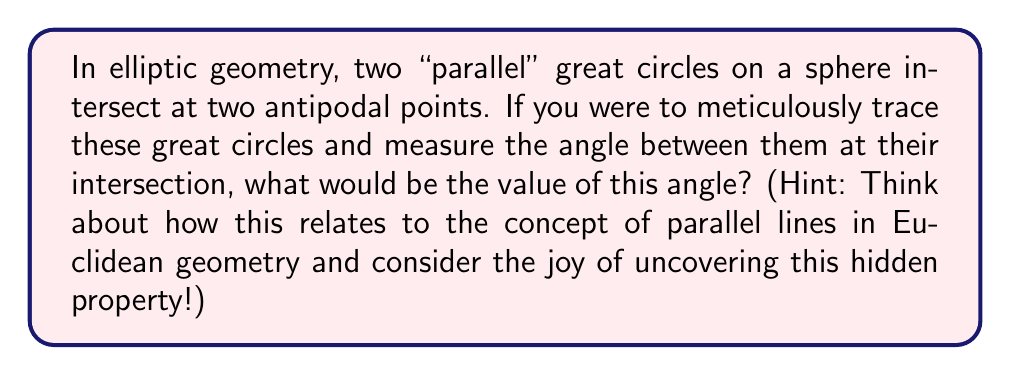Show me your answer to this math problem. Let's approach this step-by-step:

1) First, recall that in elliptic geometry, we work on the surface of a sphere. Great circles on a sphere are the equivalent of straight lines in Euclidean geometry.

2) In Euclidean geometry, parallel lines never intersect and the angle between them is always 0°.

3) However, in elliptic geometry, all great circles intersect at two antipodal points. This is a fundamental difference from Euclidean geometry.

4) To determine the angle of intersection, let's consider the properties of great circles:

   a) Any two great circles divide the sphere into four equal parts.
   b) These four parts are congruent spherical lunes.

5) Given that the great circles divide the sphere into four equal parts, each part must represent 1/4 of the full rotation around the sphere.

6) A full rotation is 360°. Therefore, each of the four parts represents:

   $$\frac{360°}{4} = 90°$$

7) The angle between the great circles at their intersection points is the same as the angle of these spherical lunes.

8) Therefore, the angle between any two great circles at their intersection is always 90°.

This result is a fascinating "easter egg" of elliptic geometry, showing how dramatically different it is from Euclidean geometry despite some superficial similarities.
Answer: 90° 